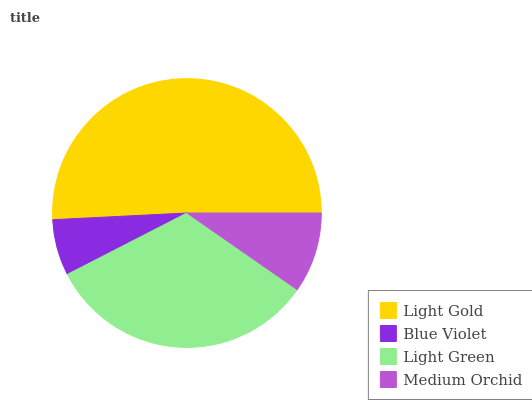Is Blue Violet the minimum?
Answer yes or no. Yes. Is Light Gold the maximum?
Answer yes or no. Yes. Is Light Green the minimum?
Answer yes or no. No. Is Light Green the maximum?
Answer yes or no. No. Is Light Green greater than Blue Violet?
Answer yes or no. Yes. Is Blue Violet less than Light Green?
Answer yes or no. Yes. Is Blue Violet greater than Light Green?
Answer yes or no. No. Is Light Green less than Blue Violet?
Answer yes or no. No. Is Light Green the high median?
Answer yes or no. Yes. Is Medium Orchid the low median?
Answer yes or no. Yes. Is Light Gold the high median?
Answer yes or no. No. Is Light Green the low median?
Answer yes or no. No. 